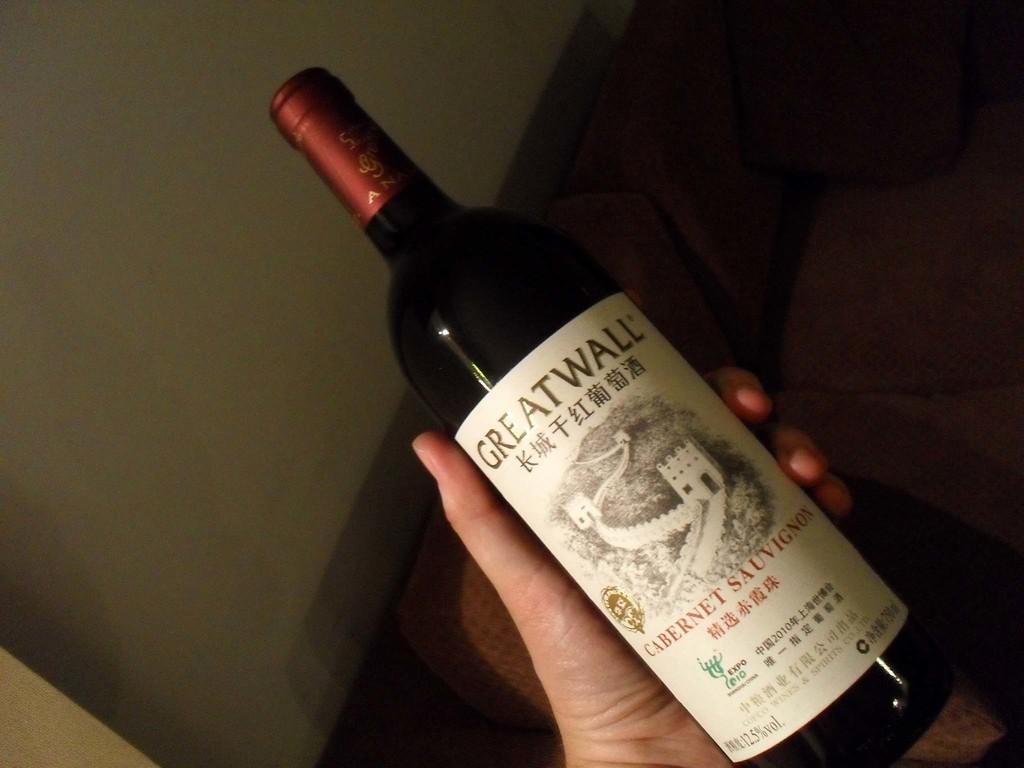What brand of wine is it?
Ensure brevity in your answer.  Great wall. 